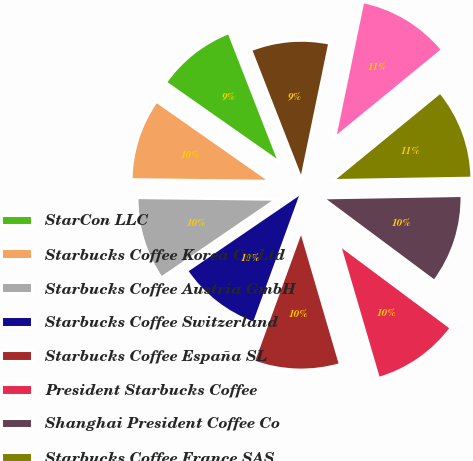<chart> <loc_0><loc_0><loc_500><loc_500><pie_chart><fcel>StarCon LLC<fcel>Starbucks Coffee Korea Co Ltd<fcel>Starbucks Coffee Austria GmbH<fcel>Starbucks Coffee Switzerland<fcel>Starbucks Coffee España SL<fcel>President Starbucks Coffee<fcel>Shanghai President Coffee Co<fcel>Starbucks Coffee France SAS<fcel>Berjaya Starbucks Coffee<fcel>Starbucks Brasil Comercio de<nl><fcel>9.35%<fcel>9.54%<fcel>9.72%<fcel>9.91%<fcel>10.09%<fcel>10.28%<fcel>10.46%<fcel>10.65%<fcel>10.83%<fcel>9.17%<nl></chart> 